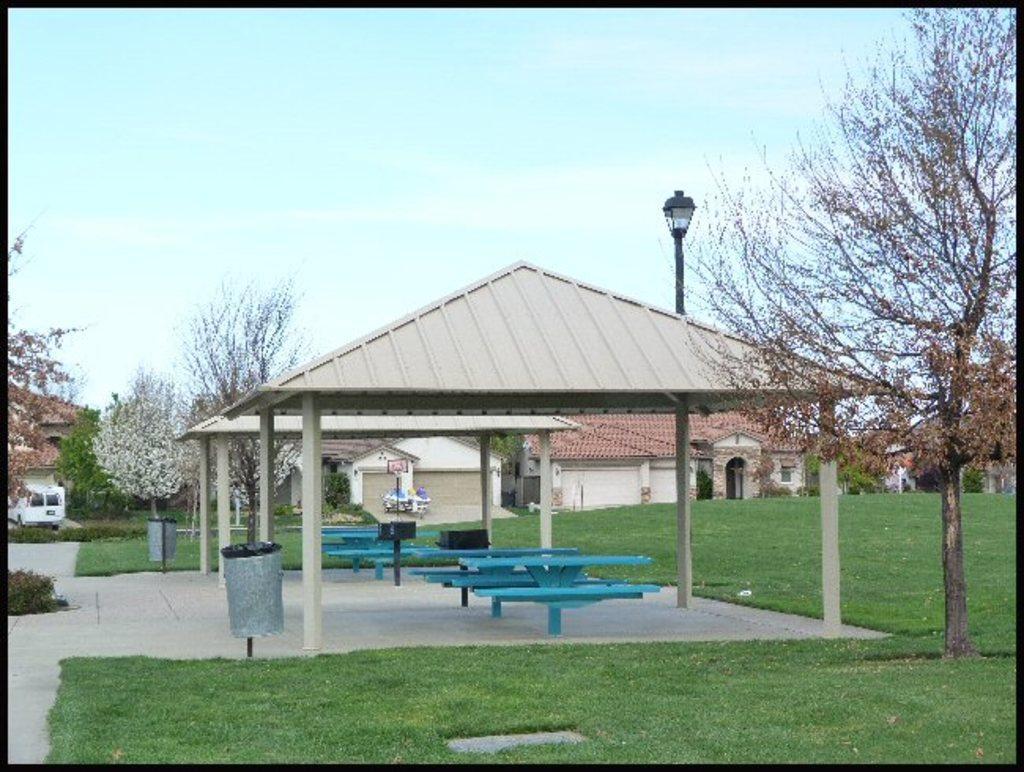How would you summarize this image in a sentence or two? In this image I can see few benches in blue color, background I can see few houses in cream, white and brown color, and trees in green color and the sky is in blue and white color. 